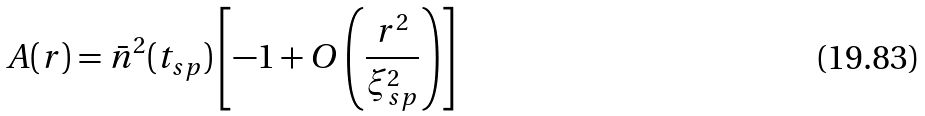Convert formula to latex. <formula><loc_0><loc_0><loc_500><loc_500>A ( r ) = { \bar { n } } ^ { 2 } ( t _ { s p } ) \left [ - 1 + O \left ( \frac { r ^ { 2 } } { \xi ^ { 2 } _ { s p } } \right ) \right ]</formula> 